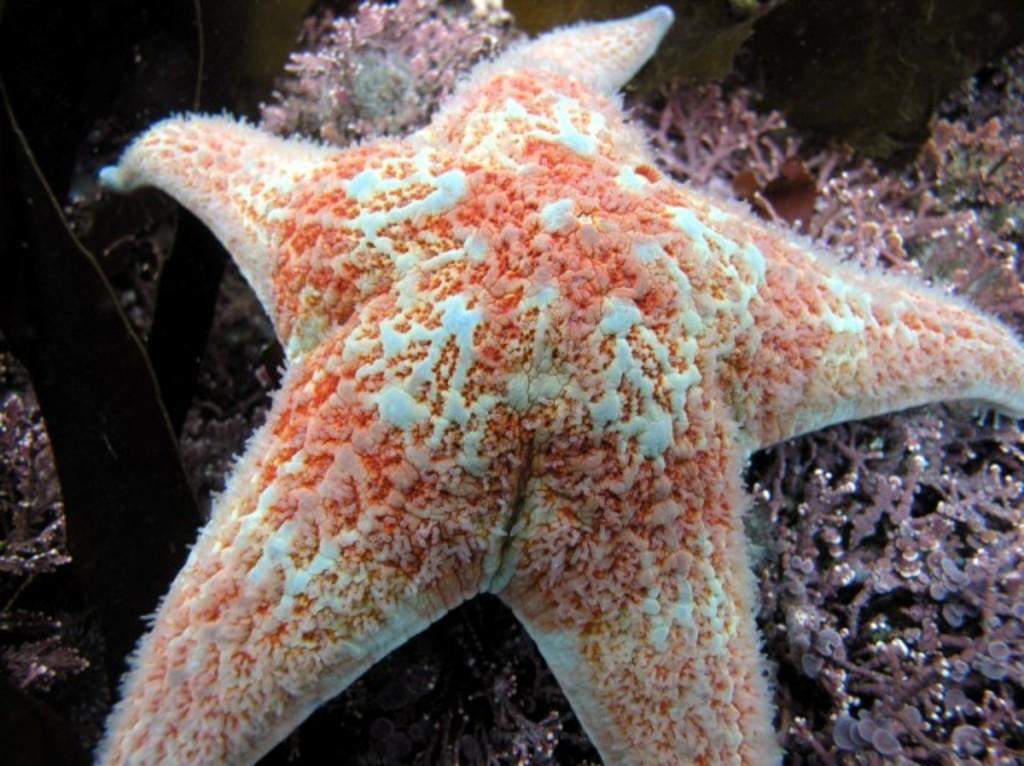What type of animal is in the image? There is a starfish in the image. Where is the starfish located? The starfish is in water. What can be seen in the background of the image? There are sea plants visible in the background of the image. What type of authority figure can be seen in the image? There is no authority figure present in the image; it features a starfish in water with sea plants in the background. 